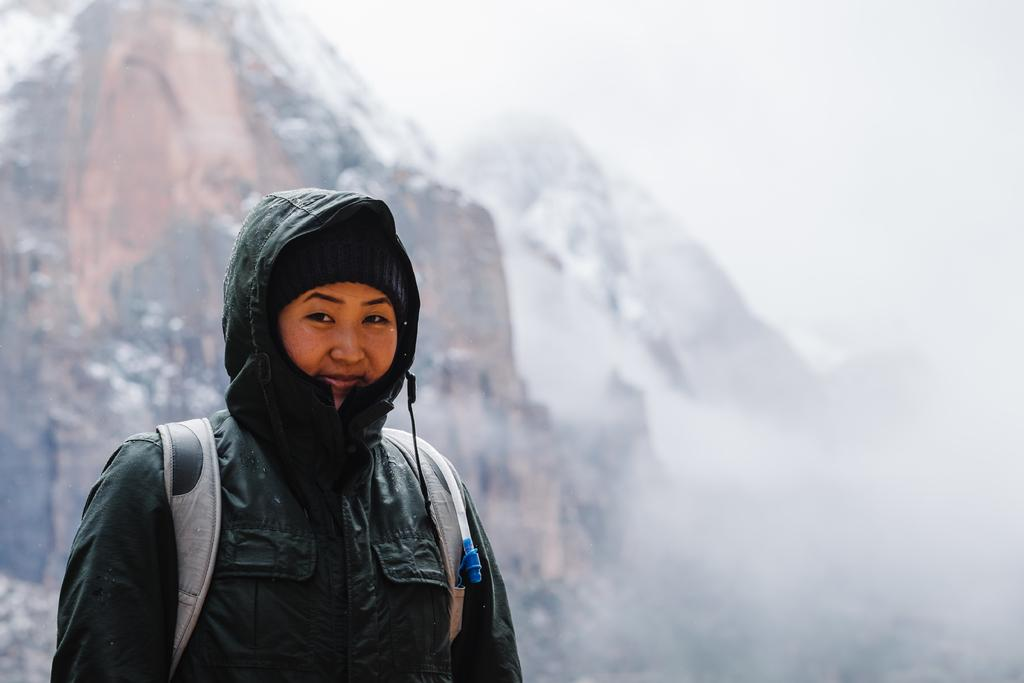Who is the main subject in the foreground of the picture? There is a woman in the foreground of the picture. What is the woman wearing? The woman is wearing a jacket. What is the woman carrying? The woman is carrying a backpack. What can be seen in the background of the picture? There are mountains and fog in the background of the picture. Where is the cannon located in the picture? There is no cannon present in the picture. What type of mist can be seen in the image? The term "mist" is not mentioned in the provided facts, but there is fog visible in the background of the picture. 